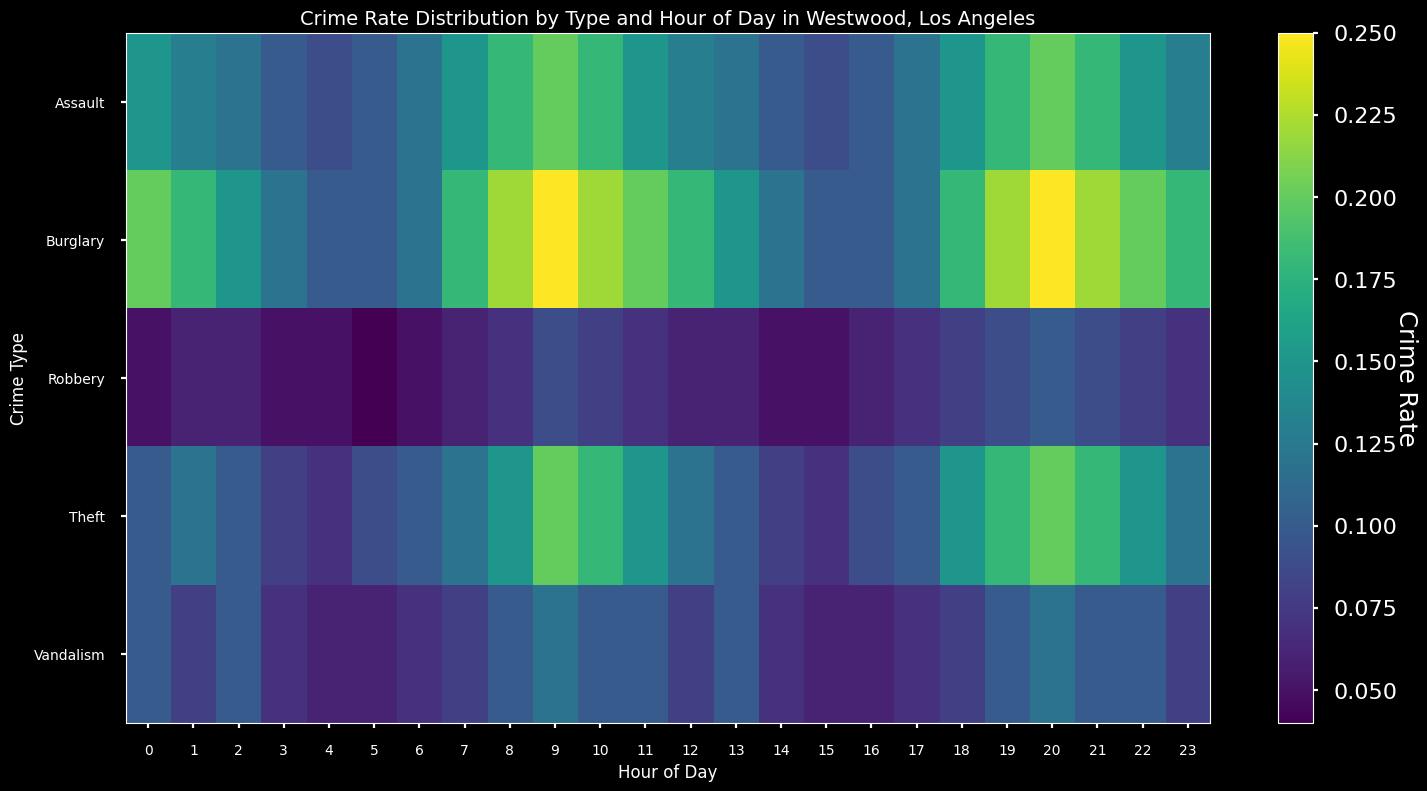What hour of the day has the highest crime rate for Burglary? The hour of the day with the highest value in the Burglary row corresponds to the highest crime rate for this type. From the figure, the brightest color on the Burglary row is at hour 9 and hour 20.
Answer: 9 and 20 Which crime type has the lowest rate at 2 AM? Locate the column for hour 2 and identify the value with the darkest shade of color, which indicates the lowest crime rate among all crime types at this hour. The darkest shade corresponds to Robbery.
Answer: Robbery How does the crime rate for Assault at 10 PM compare to that at 10 AM? Find the Assault row and compare the values at columns 22 (10 PM) and 10 (10 AM). Both values should be visually inspected for lighter shades indicating higher rates. At both hours, the crime rate for Assault is the same at 0.18.
Answer: Equal Are there any hours where the crime rate for Theft is the same as for Vandalism? Look at the Theft and Vandalism rows and compare their color shades across each hour of the day. At hours like 6, 11, 19, 21, they have the same values of 0.10.
Answer: Yes, for example at hours 6, 11, 19, 21 What's the difference in the crime rate for Burglary between 1 AM and 1 PM? Note the Burglary values for hours 1 and 13, which are 0.18 and 0.15, respectively. Subtract the rate at 1 PM from the rate at 1 AM. Therefore, 0.18 - 0.15 = 0.03.
Answer: 0.03 During which hour is Vandalism most frequent? Identify the hour with the lightest color shade in the Vandalism row, indicating the highest crime rate. Hour 20, with a rate of 0.12, stands out.
Answer: 20 (8 PM) Which hour has the highest total crime rate across all types? Sum the crime rates for each hour across all types and identify the hour with the highest total. Hour 20 has the highest summed value (0.25+0.20+0.10+0.20+0.12 = 0.87).
Answer: 20 At what hour does Robbery show the highest rate and what is that rate? Look at the Robbery row and find the hour with the lightest color shade. The highest value, 0.10, is at hour 20.
Answer: 20, 0.10 How does the crime rate for Burglary at midnight compare with 6 AM? The Burglary values for hours 0 and 6 are 0.20 and 0.12, respectively. Comparing these, the rate at midnight is higher.
Answer: Higher at midnight Is there an hour when the crime rates for all types are at their lowest? Check each column to see if there's a consistent dark shade across all rows indicating the lowest rates. Hour 4 shows relatively darker shades across all types compared to other hours (Burglary: 0.1, Assault: 0.09, Robbery: 0.05, Theft: 0.07, Vandalism: 0.06).
Answer: Hour 4 